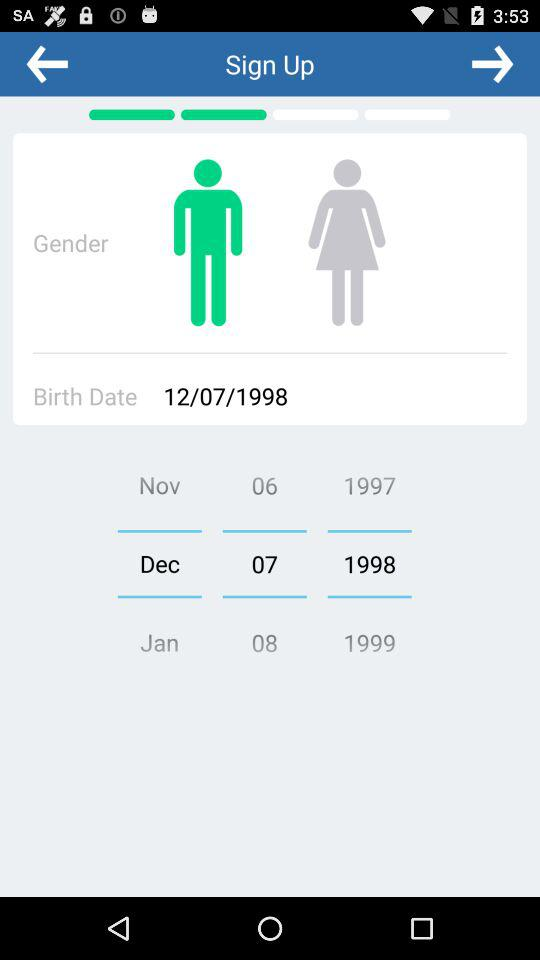What is the selected gender? The selected gender is male. 